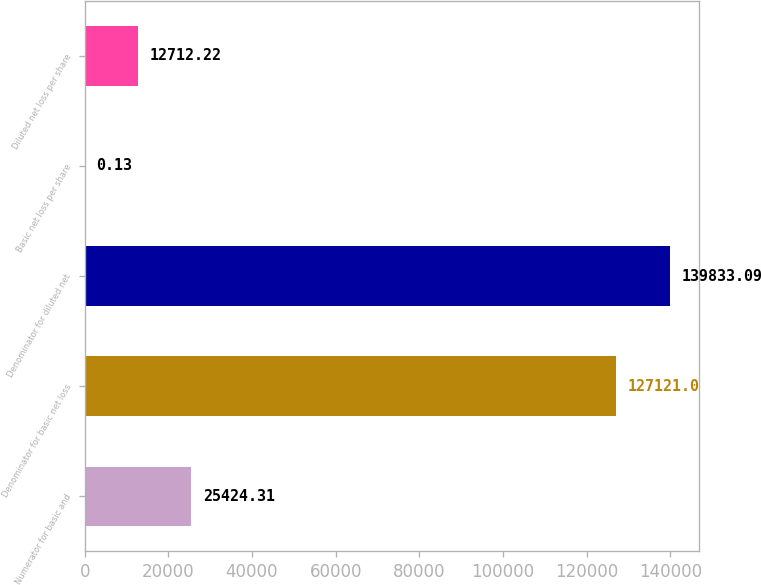<chart> <loc_0><loc_0><loc_500><loc_500><bar_chart><fcel>Numerator for basic and<fcel>Denominator for basic net loss<fcel>Denominator for diluted net<fcel>Basic net loss per share<fcel>Diluted net loss per share<nl><fcel>25424.3<fcel>127121<fcel>139833<fcel>0.13<fcel>12712.2<nl></chart> 